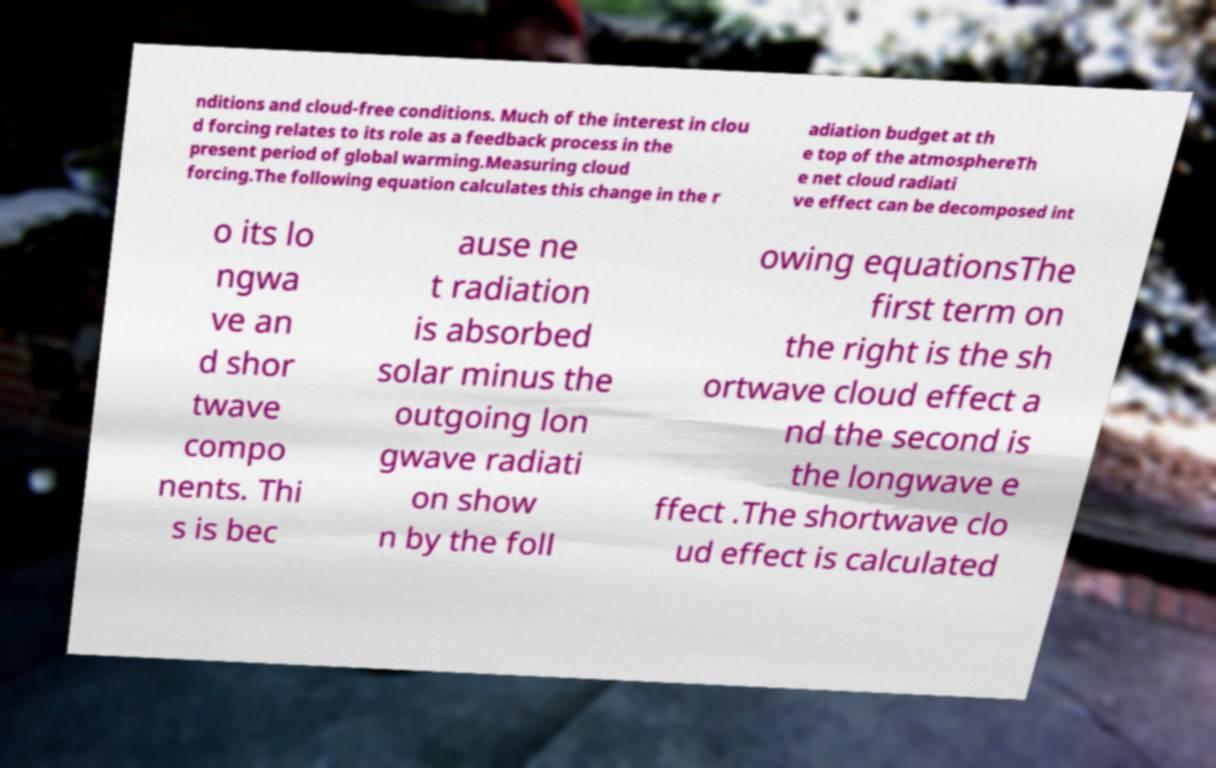What messages or text are displayed in this image? I need them in a readable, typed format. nditions and cloud-free conditions. Much of the interest in clou d forcing relates to its role as a feedback process in the present period of global warming.Measuring cloud forcing.The following equation calculates this change in the r adiation budget at th e top of the atmosphereTh e net cloud radiati ve effect can be decomposed int o its lo ngwa ve an d shor twave compo nents. Thi s is bec ause ne t radiation is absorbed solar minus the outgoing lon gwave radiati on show n by the foll owing equationsThe first term on the right is the sh ortwave cloud effect a nd the second is the longwave e ffect .The shortwave clo ud effect is calculated 